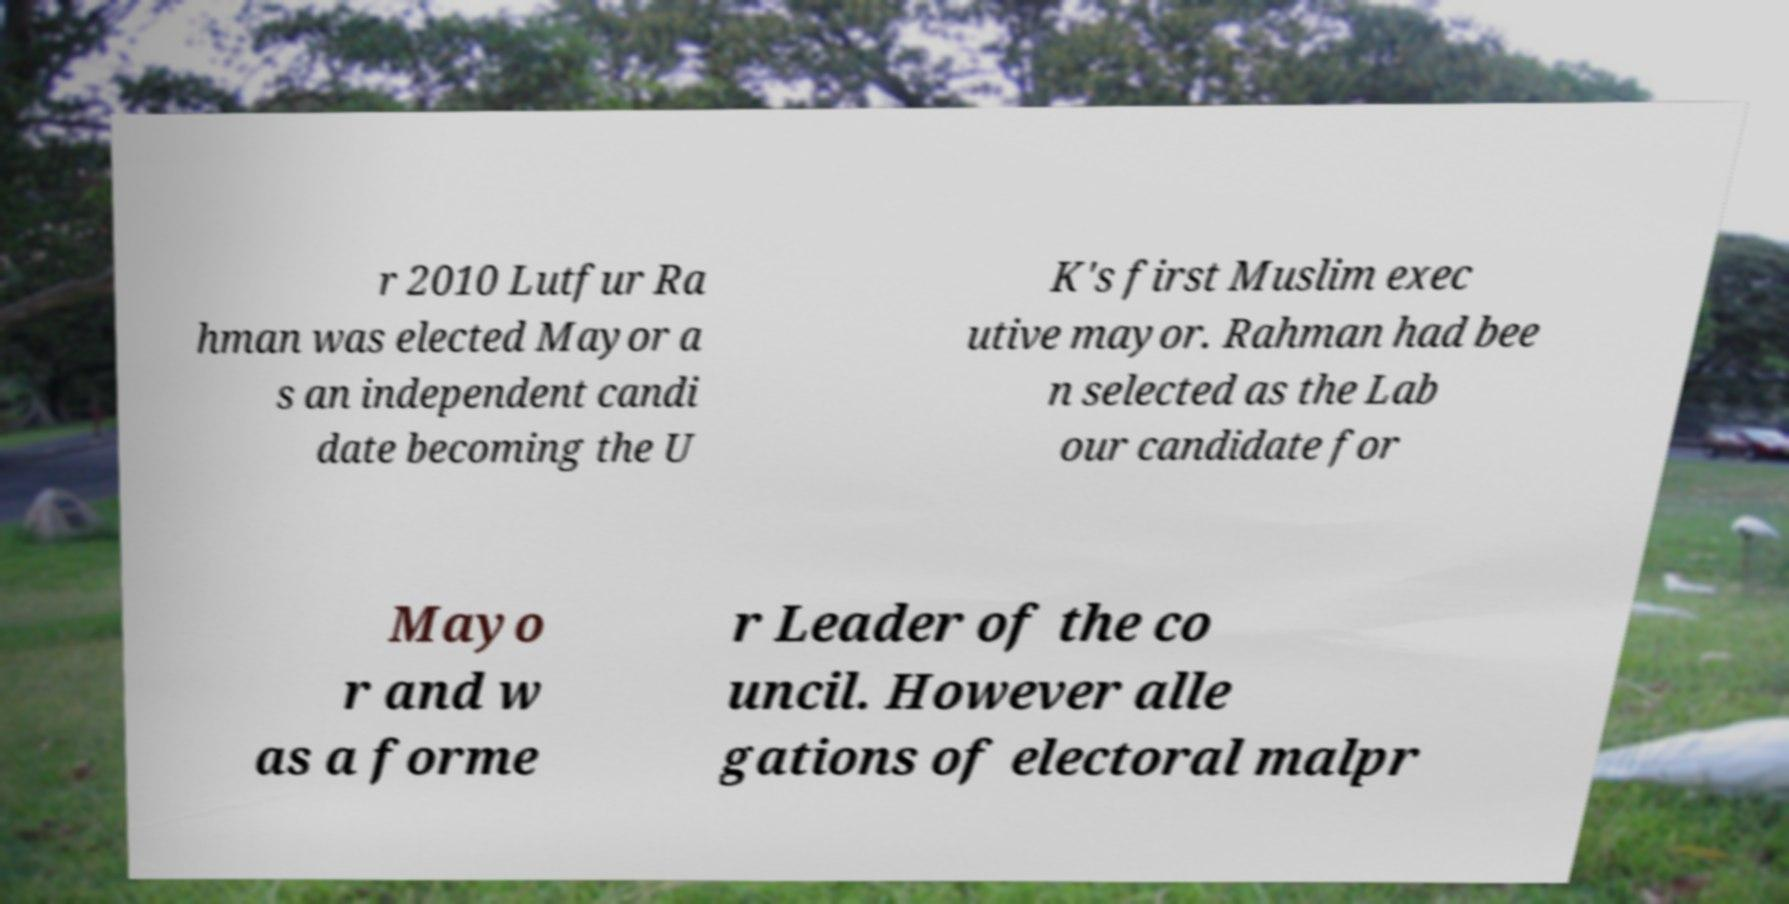There's text embedded in this image that I need extracted. Can you transcribe it verbatim? r 2010 Lutfur Ra hman was elected Mayor a s an independent candi date becoming the U K's first Muslim exec utive mayor. Rahman had bee n selected as the Lab our candidate for Mayo r and w as a forme r Leader of the co uncil. However alle gations of electoral malpr 